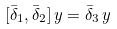<formula> <loc_0><loc_0><loc_500><loc_500>[ \bar { \delta } _ { 1 } , \bar { \delta } _ { 2 } ] \, y = \bar { \delta } _ { 3 } \, y</formula> 